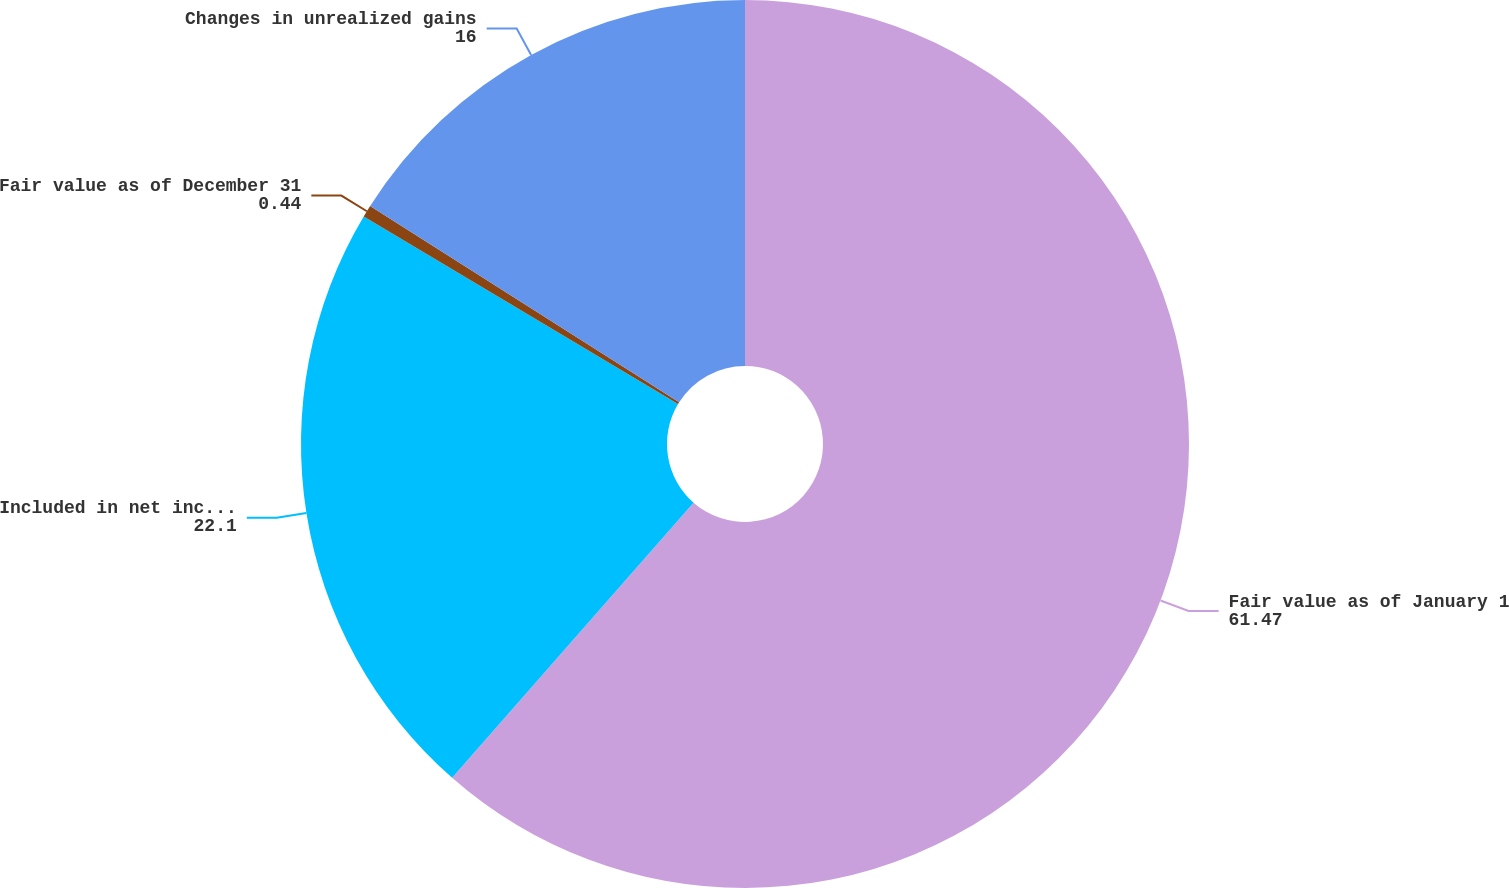Convert chart. <chart><loc_0><loc_0><loc_500><loc_500><pie_chart><fcel>Fair value as of January 1<fcel>Included in net income 1 2 6<fcel>Fair value as of December 31<fcel>Changes in unrealized gains<nl><fcel>61.47%<fcel>22.1%<fcel>0.44%<fcel>16.0%<nl></chart> 